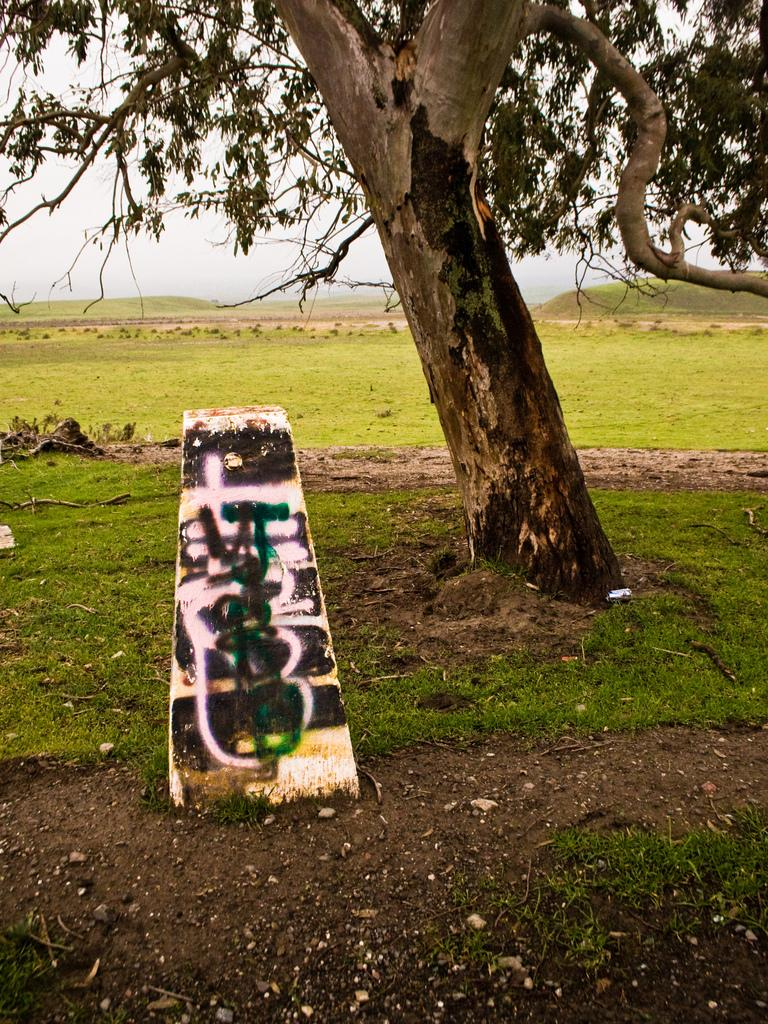What type of terrain is visible in the image? There is an open grass ground in the image. Are there any natural elements present in the image? Yes, there is a tree in the image. What is the white object in the image? The white object in the image is a canvas or surface that has spray paintings on it. What type of flower is growing at the base of the tree in the image? There is no flower mentioned or visible in the image. 